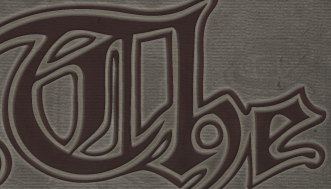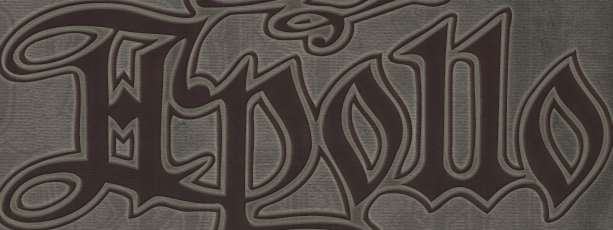What words can you see in these images in sequence, separated by a semicolon? The; Hpollo 